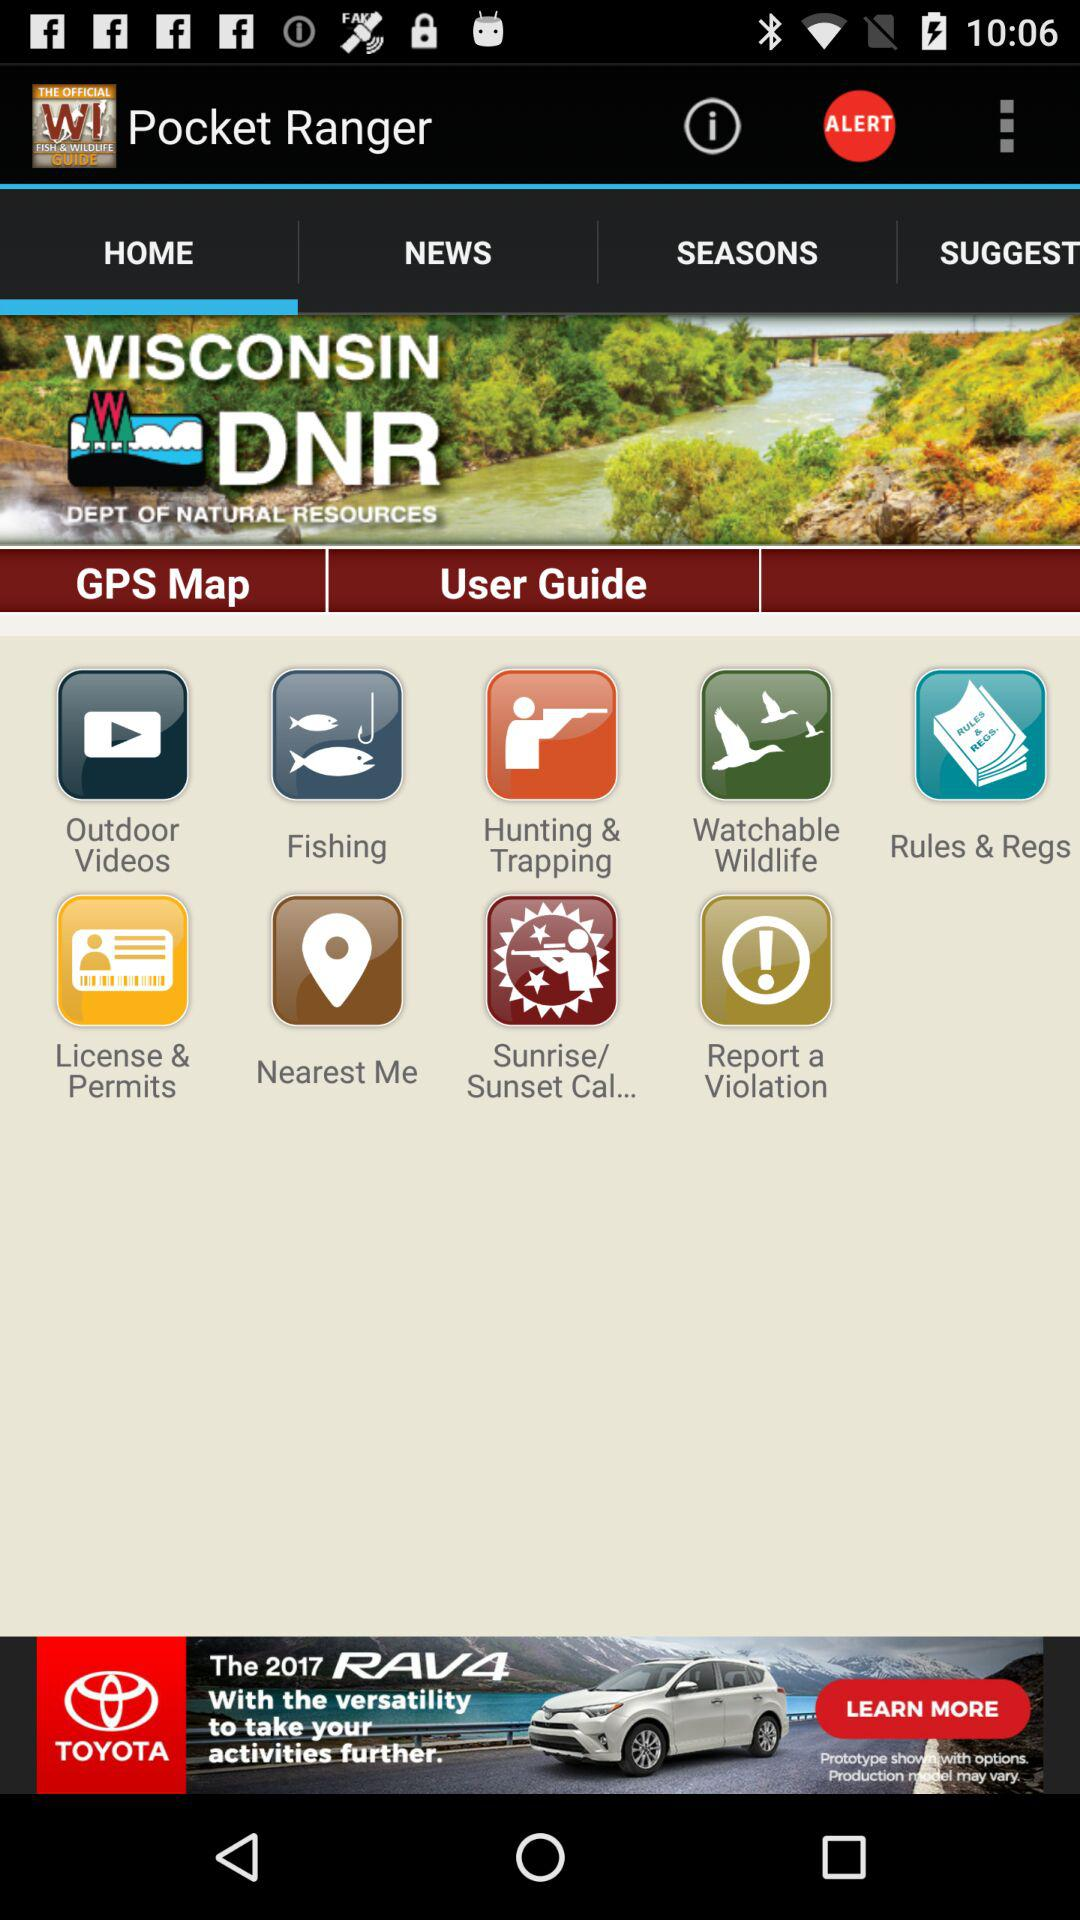Which option is selected in "Pocket Ranger"? The selected option is "HOME". 